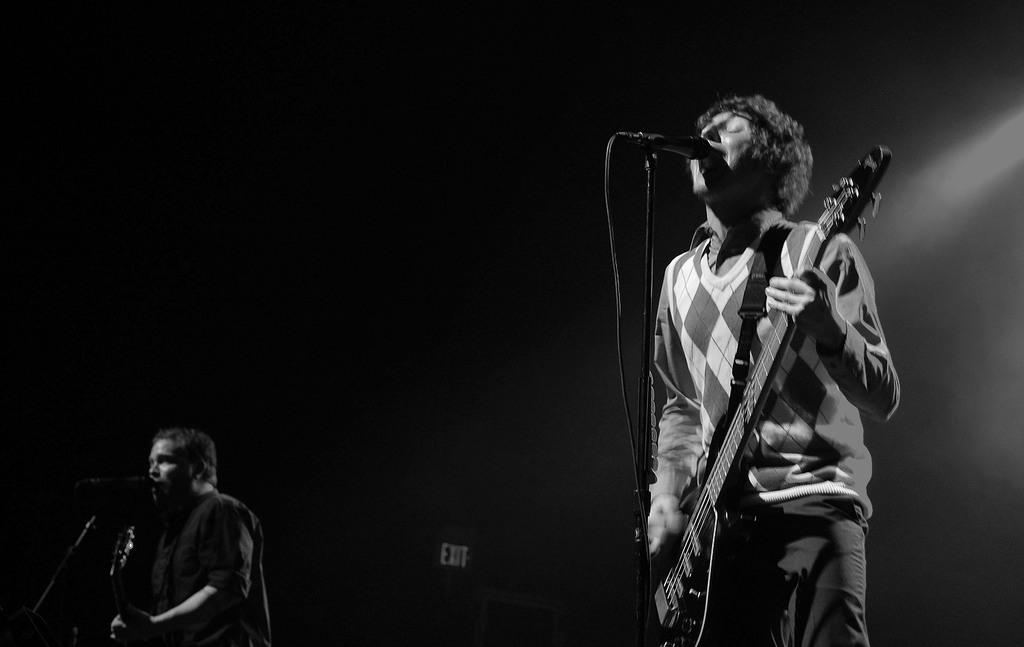What is the person holding in the image? The person is holding a guitar. What can be seen in front of the person? There is a mic and a mic holder in front of the person. Are there any other mics visible in the image? Yes, there is another mic in front of the person. How many cats are sitting on the desk in the image? There is no desk or cats present in the image. 